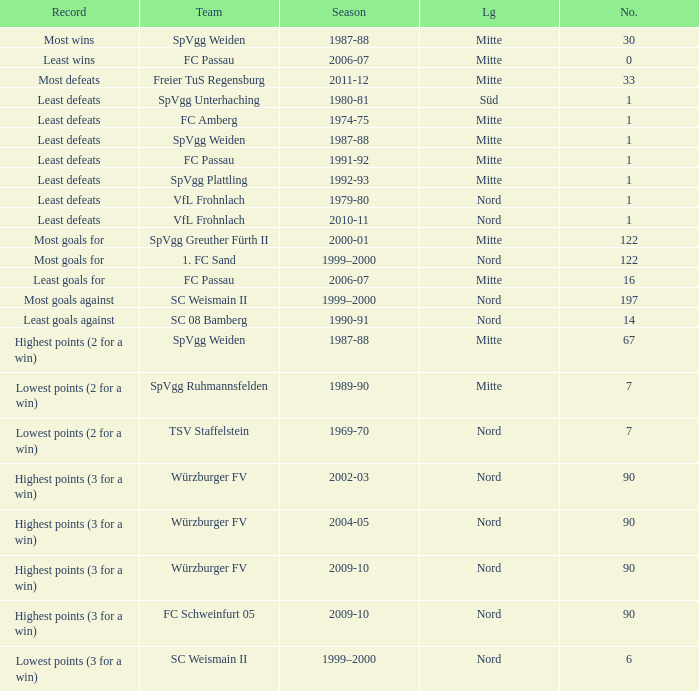What season has a number less than 90, Mitte as the league and spvgg ruhmannsfelden as the team? 1989-90. 